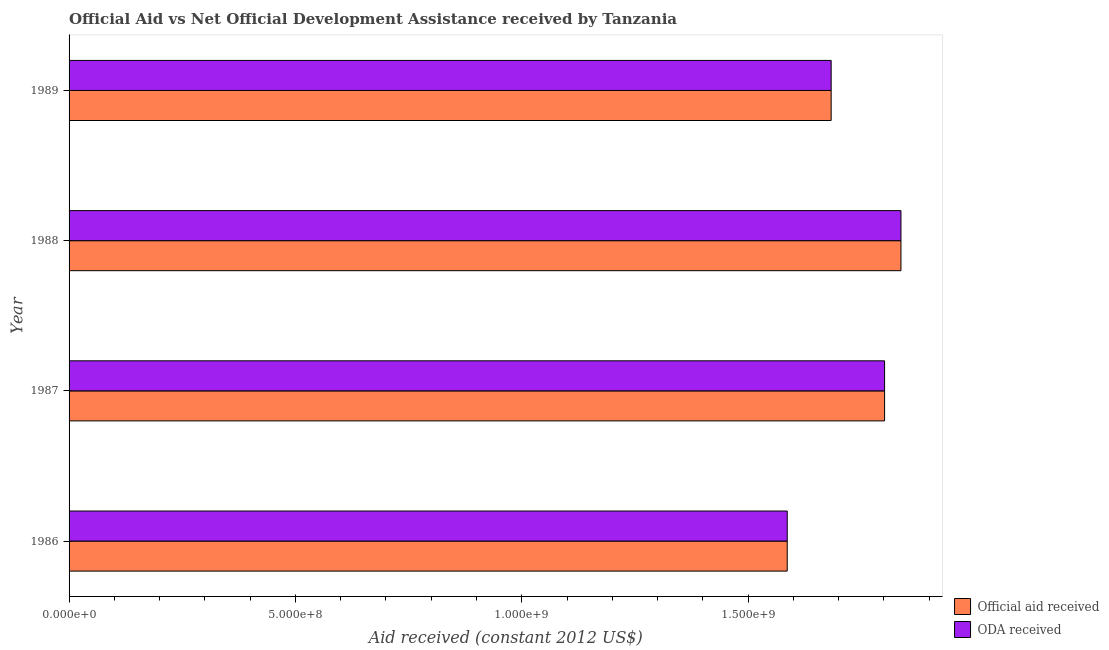How many different coloured bars are there?
Keep it short and to the point. 2. Are the number of bars on each tick of the Y-axis equal?
Give a very brief answer. Yes. How many bars are there on the 3rd tick from the bottom?
Ensure brevity in your answer.  2. In how many cases, is the number of bars for a given year not equal to the number of legend labels?
Make the answer very short. 0. What is the official aid received in 1986?
Ensure brevity in your answer.  1.59e+09. Across all years, what is the maximum oda received?
Your response must be concise. 1.84e+09. Across all years, what is the minimum official aid received?
Offer a very short reply. 1.59e+09. In which year was the official aid received maximum?
Make the answer very short. 1988. What is the total oda received in the graph?
Your answer should be compact. 6.91e+09. What is the difference between the oda received in 1988 and that in 1989?
Provide a succinct answer. 1.54e+08. What is the difference between the official aid received in 1989 and the oda received in 1986?
Your response must be concise. 9.70e+07. What is the average oda received per year?
Your answer should be very brief. 1.73e+09. What is the ratio of the official aid received in 1988 to that in 1989?
Keep it short and to the point. 1.09. Is the difference between the official aid received in 1987 and 1988 greater than the difference between the oda received in 1987 and 1988?
Your answer should be very brief. No. What is the difference between the highest and the second highest official aid received?
Offer a terse response. 3.62e+07. What is the difference between the highest and the lowest official aid received?
Your response must be concise. 2.51e+08. In how many years, is the oda received greater than the average oda received taken over all years?
Provide a succinct answer. 2. Is the sum of the official aid received in 1986 and 1987 greater than the maximum oda received across all years?
Offer a very short reply. Yes. What does the 1st bar from the top in 1987 represents?
Offer a terse response. ODA received. What does the 1st bar from the bottom in 1987 represents?
Make the answer very short. Official aid received. Are the values on the major ticks of X-axis written in scientific E-notation?
Make the answer very short. Yes. Does the graph contain any zero values?
Ensure brevity in your answer.  No. How many legend labels are there?
Make the answer very short. 2. How are the legend labels stacked?
Provide a short and direct response. Vertical. What is the title of the graph?
Your answer should be compact. Official Aid vs Net Official Development Assistance received by Tanzania . What is the label or title of the X-axis?
Keep it short and to the point. Aid received (constant 2012 US$). What is the Aid received (constant 2012 US$) in Official aid received in 1986?
Your answer should be very brief. 1.59e+09. What is the Aid received (constant 2012 US$) in ODA received in 1986?
Ensure brevity in your answer.  1.59e+09. What is the Aid received (constant 2012 US$) of Official aid received in 1987?
Make the answer very short. 1.80e+09. What is the Aid received (constant 2012 US$) of ODA received in 1987?
Your answer should be very brief. 1.80e+09. What is the Aid received (constant 2012 US$) in Official aid received in 1988?
Ensure brevity in your answer.  1.84e+09. What is the Aid received (constant 2012 US$) in ODA received in 1988?
Your answer should be very brief. 1.84e+09. What is the Aid received (constant 2012 US$) in Official aid received in 1989?
Ensure brevity in your answer.  1.68e+09. What is the Aid received (constant 2012 US$) of ODA received in 1989?
Provide a succinct answer. 1.68e+09. Across all years, what is the maximum Aid received (constant 2012 US$) of Official aid received?
Offer a terse response. 1.84e+09. Across all years, what is the maximum Aid received (constant 2012 US$) of ODA received?
Make the answer very short. 1.84e+09. Across all years, what is the minimum Aid received (constant 2012 US$) of Official aid received?
Offer a terse response. 1.59e+09. Across all years, what is the minimum Aid received (constant 2012 US$) of ODA received?
Provide a succinct answer. 1.59e+09. What is the total Aid received (constant 2012 US$) in Official aid received in the graph?
Give a very brief answer. 6.91e+09. What is the total Aid received (constant 2012 US$) in ODA received in the graph?
Your answer should be very brief. 6.91e+09. What is the difference between the Aid received (constant 2012 US$) of Official aid received in 1986 and that in 1987?
Ensure brevity in your answer.  -2.15e+08. What is the difference between the Aid received (constant 2012 US$) of ODA received in 1986 and that in 1987?
Give a very brief answer. -2.15e+08. What is the difference between the Aid received (constant 2012 US$) of Official aid received in 1986 and that in 1988?
Provide a succinct answer. -2.51e+08. What is the difference between the Aid received (constant 2012 US$) in ODA received in 1986 and that in 1988?
Make the answer very short. -2.51e+08. What is the difference between the Aid received (constant 2012 US$) of Official aid received in 1986 and that in 1989?
Offer a very short reply. -9.70e+07. What is the difference between the Aid received (constant 2012 US$) of ODA received in 1986 and that in 1989?
Provide a short and direct response. -9.70e+07. What is the difference between the Aid received (constant 2012 US$) of Official aid received in 1987 and that in 1988?
Provide a succinct answer. -3.62e+07. What is the difference between the Aid received (constant 2012 US$) in ODA received in 1987 and that in 1988?
Keep it short and to the point. -3.62e+07. What is the difference between the Aid received (constant 2012 US$) in Official aid received in 1987 and that in 1989?
Ensure brevity in your answer.  1.18e+08. What is the difference between the Aid received (constant 2012 US$) in ODA received in 1987 and that in 1989?
Offer a very short reply. 1.18e+08. What is the difference between the Aid received (constant 2012 US$) in Official aid received in 1988 and that in 1989?
Your answer should be compact. 1.54e+08. What is the difference between the Aid received (constant 2012 US$) of ODA received in 1988 and that in 1989?
Keep it short and to the point. 1.54e+08. What is the difference between the Aid received (constant 2012 US$) in Official aid received in 1986 and the Aid received (constant 2012 US$) in ODA received in 1987?
Provide a succinct answer. -2.15e+08. What is the difference between the Aid received (constant 2012 US$) in Official aid received in 1986 and the Aid received (constant 2012 US$) in ODA received in 1988?
Provide a short and direct response. -2.51e+08. What is the difference between the Aid received (constant 2012 US$) in Official aid received in 1986 and the Aid received (constant 2012 US$) in ODA received in 1989?
Give a very brief answer. -9.70e+07. What is the difference between the Aid received (constant 2012 US$) in Official aid received in 1987 and the Aid received (constant 2012 US$) in ODA received in 1988?
Offer a very short reply. -3.62e+07. What is the difference between the Aid received (constant 2012 US$) of Official aid received in 1987 and the Aid received (constant 2012 US$) of ODA received in 1989?
Your answer should be very brief. 1.18e+08. What is the difference between the Aid received (constant 2012 US$) of Official aid received in 1988 and the Aid received (constant 2012 US$) of ODA received in 1989?
Offer a very short reply. 1.54e+08. What is the average Aid received (constant 2012 US$) in Official aid received per year?
Provide a succinct answer. 1.73e+09. What is the average Aid received (constant 2012 US$) of ODA received per year?
Your answer should be compact. 1.73e+09. In the year 1986, what is the difference between the Aid received (constant 2012 US$) of Official aid received and Aid received (constant 2012 US$) of ODA received?
Offer a terse response. 0. In the year 1988, what is the difference between the Aid received (constant 2012 US$) of Official aid received and Aid received (constant 2012 US$) of ODA received?
Your answer should be compact. 0. What is the ratio of the Aid received (constant 2012 US$) in Official aid received in 1986 to that in 1987?
Your response must be concise. 0.88. What is the ratio of the Aid received (constant 2012 US$) in ODA received in 1986 to that in 1987?
Provide a succinct answer. 0.88. What is the ratio of the Aid received (constant 2012 US$) in Official aid received in 1986 to that in 1988?
Ensure brevity in your answer.  0.86. What is the ratio of the Aid received (constant 2012 US$) in ODA received in 1986 to that in 1988?
Keep it short and to the point. 0.86. What is the ratio of the Aid received (constant 2012 US$) of Official aid received in 1986 to that in 1989?
Your response must be concise. 0.94. What is the ratio of the Aid received (constant 2012 US$) of ODA received in 1986 to that in 1989?
Give a very brief answer. 0.94. What is the ratio of the Aid received (constant 2012 US$) of Official aid received in 1987 to that in 1988?
Offer a terse response. 0.98. What is the ratio of the Aid received (constant 2012 US$) in ODA received in 1987 to that in 1988?
Provide a short and direct response. 0.98. What is the ratio of the Aid received (constant 2012 US$) in Official aid received in 1987 to that in 1989?
Provide a succinct answer. 1.07. What is the ratio of the Aid received (constant 2012 US$) in ODA received in 1987 to that in 1989?
Your response must be concise. 1.07. What is the ratio of the Aid received (constant 2012 US$) of Official aid received in 1988 to that in 1989?
Your answer should be compact. 1.09. What is the ratio of the Aid received (constant 2012 US$) of ODA received in 1988 to that in 1989?
Offer a very short reply. 1.09. What is the difference between the highest and the second highest Aid received (constant 2012 US$) of Official aid received?
Offer a very short reply. 3.62e+07. What is the difference between the highest and the second highest Aid received (constant 2012 US$) of ODA received?
Your answer should be compact. 3.62e+07. What is the difference between the highest and the lowest Aid received (constant 2012 US$) of Official aid received?
Keep it short and to the point. 2.51e+08. What is the difference between the highest and the lowest Aid received (constant 2012 US$) of ODA received?
Provide a succinct answer. 2.51e+08. 